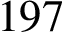<formula> <loc_0><loc_0><loc_500><loc_500>1 9 7</formula> 